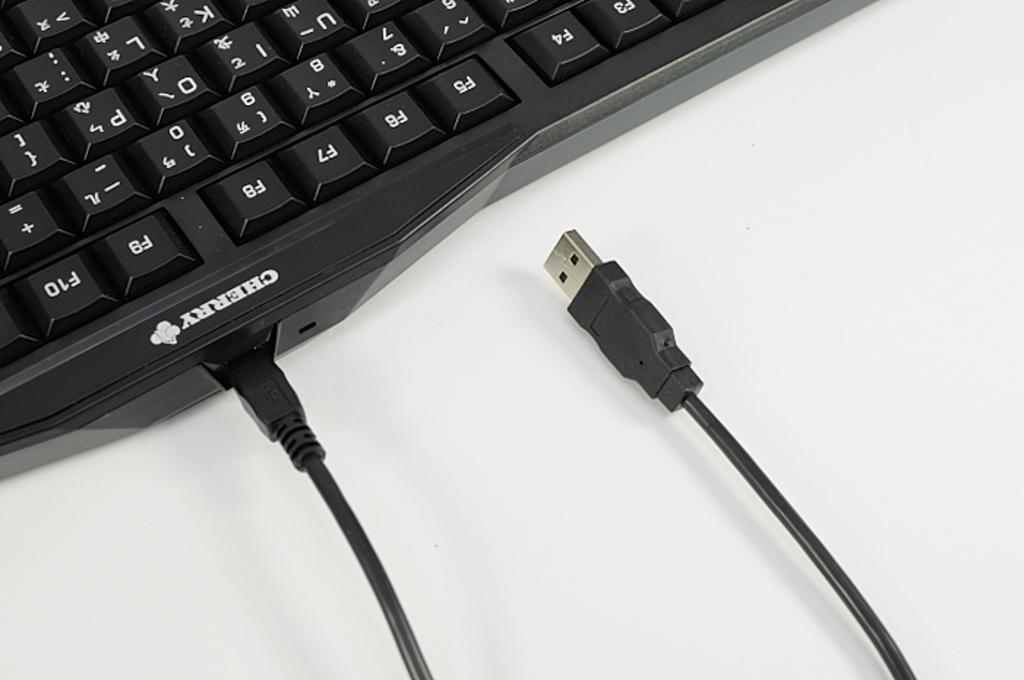What brand is at the top of the keyboard?
Make the answer very short. Cherry. What letters are on this keyboard?
Your response must be concise. Uiopkl. 